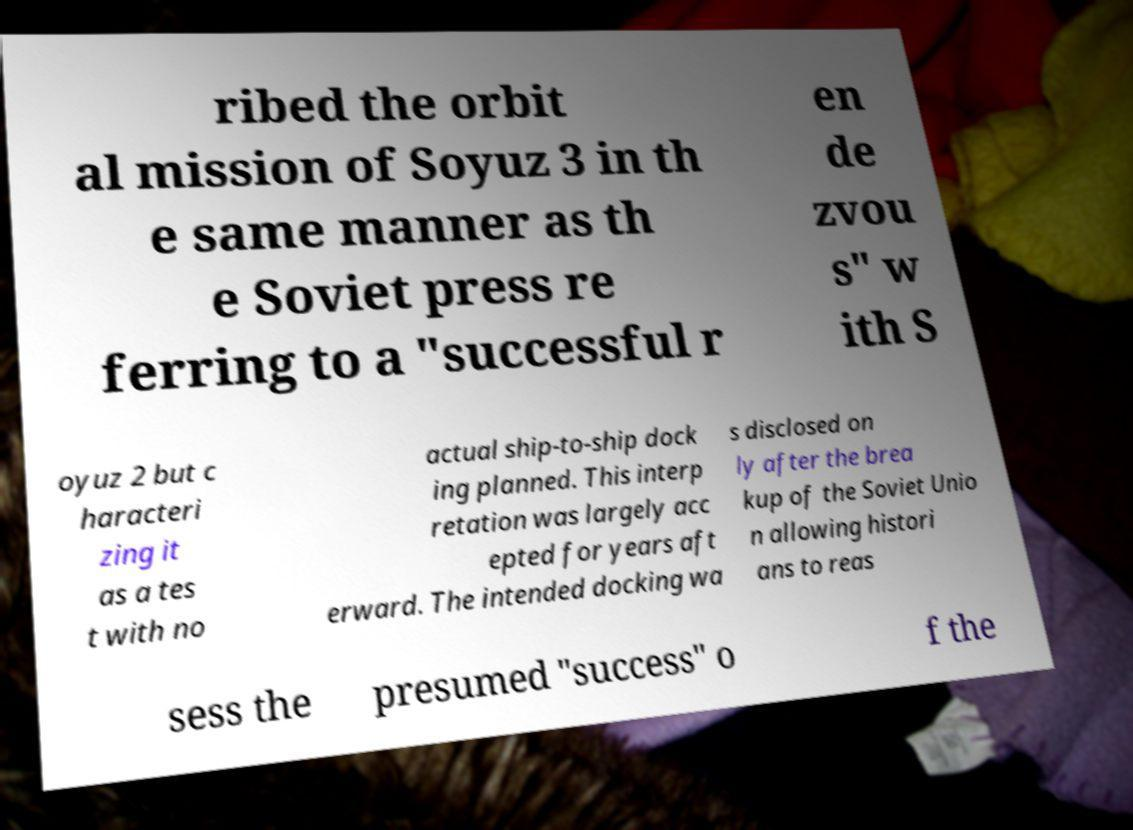Could you extract and type out the text from this image? ribed the orbit al mission of Soyuz 3 in th e same manner as th e Soviet press re ferring to a "successful r en de zvou s" w ith S oyuz 2 but c haracteri zing it as a tes t with no actual ship-to-ship dock ing planned. This interp retation was largely acc epted for years aft erward. The intended docking wa s disclosed on ly after the brea kup of the Soviet Unio n allowing histori ans to reas sess the presumed "success" o f the 